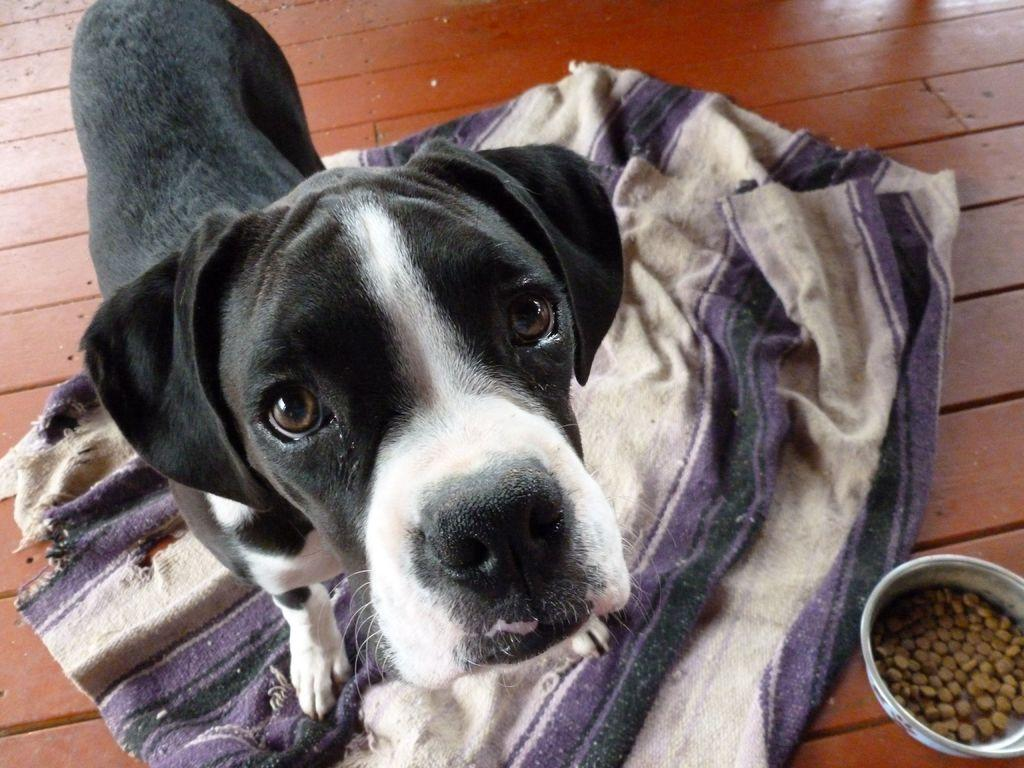What type of animal is present in the image? There is a dog in the image. What is visible behind the dog? There is cloth visible behind the dog. Where is the bowl located in the image? The bowl is in the bottom right corner of the image. What is in the bowl? The bowl contains nuts. What type of plants can be seen growing near the dog in the image? There are no plants visible in the image; it only features a dog, cloth, and a bowl of nuts. 